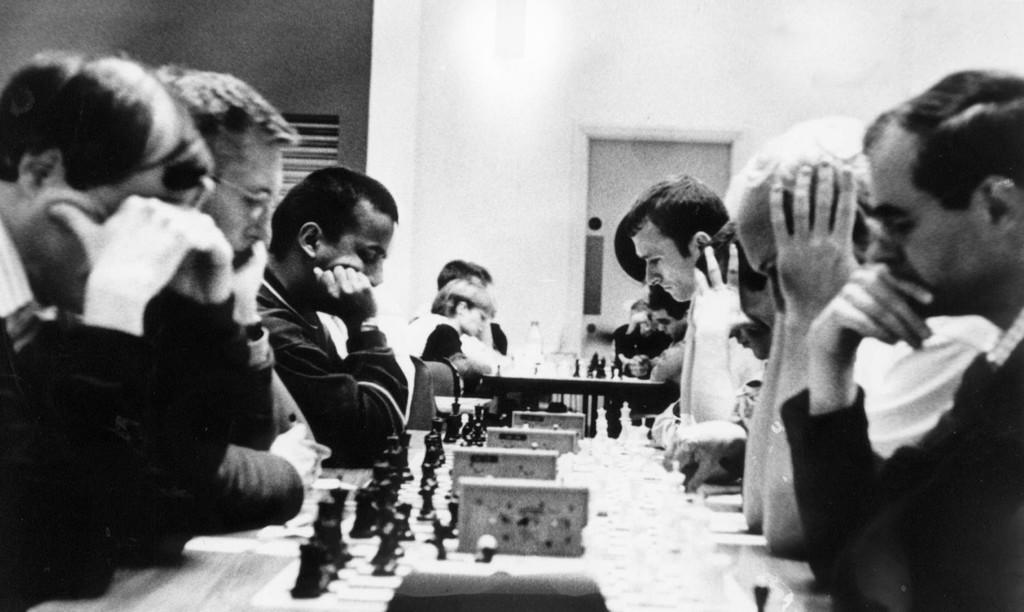What is the color scheme of the image? The image is black and white. What activity are the people engaged in? People are playing chess in the image. How many islands can be seen in the image? There are no islands present in the image; it features people playing chess in a black and white setting. What type of power source is used to light the chessboard in the image? There is no indication of a power source or lighting in the image, as it is black and white and does not show any electrical components. 